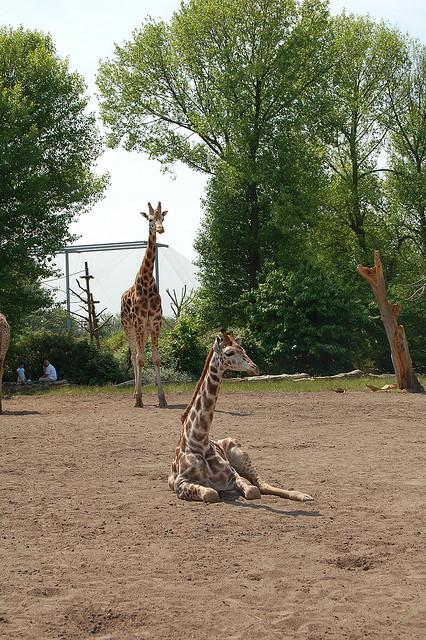What is the giraffe in the foreground doing?

Choices:
A) jumping
B) sitting
C) running
D) eating grass sitting 